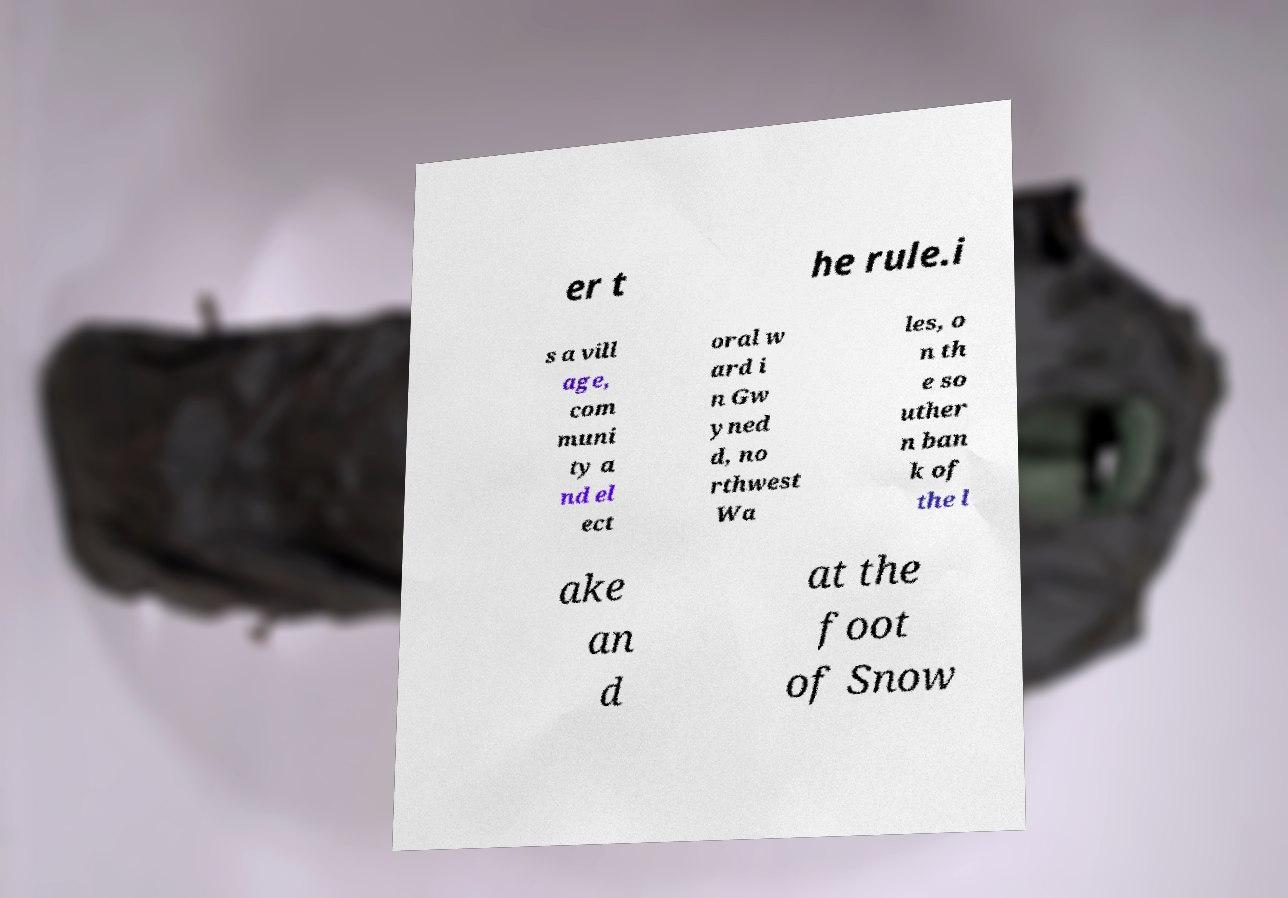Can you read and provide the text displayed in the image?This photo seems to have some interesting text. Can you extract and type it out for me? er t he rule.i s a vill age, com muni ty a nd el ect oral w ard i n Gw yned d, no rthwest Wa les, o n th e so uther n ban k of the l ake an d at the foot of Snow 